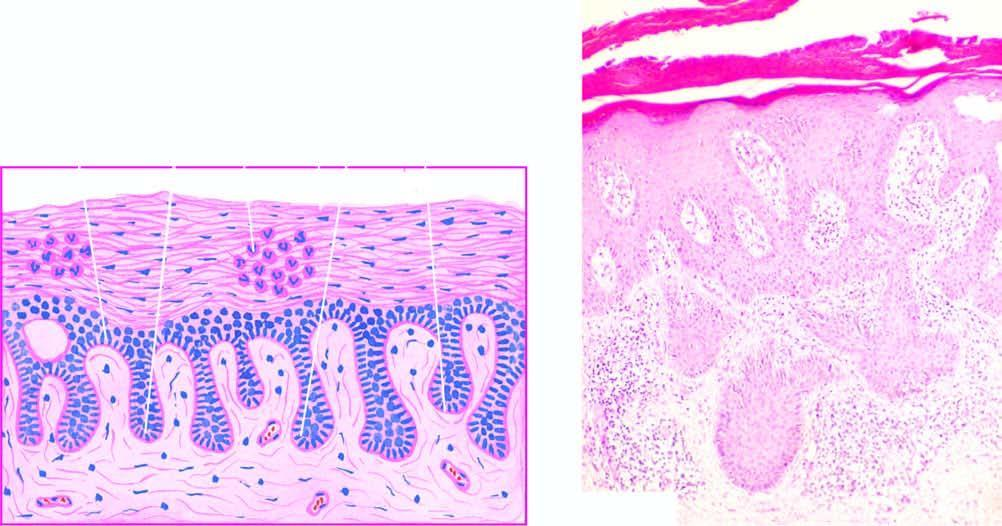re two multi-faceted gallstones elongated and oedematous with suprapapillary thinning of epidermis?
Answer the question using a single word or phrase. No 